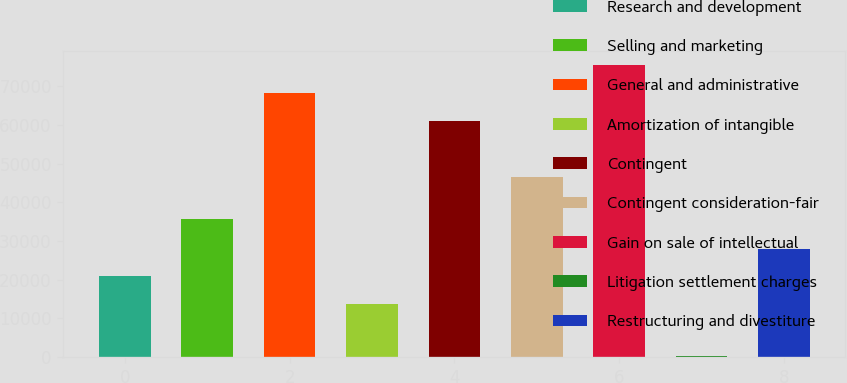Convert chart to OTSL. <chart><loc_0><loc_0><loc_500><loc_500><bar_chart><fcel>Research and development<fcel>Selling and marketing<fcel>General and administrative<fcel>Amortization of intangible<fcel>Contingent<fcel>Contingent consideration-fair<fcel>Gain on sale of intellectual<fcel>Litigation settlement charges<fcel>Restructuring and divestiture<nl><fcel>20878<fcel>35584<fcel>68205<fcel>13702<fcel>61029<fcel>46482<fcel>75381<fcel>318<fcel>28054<nl></chart> 